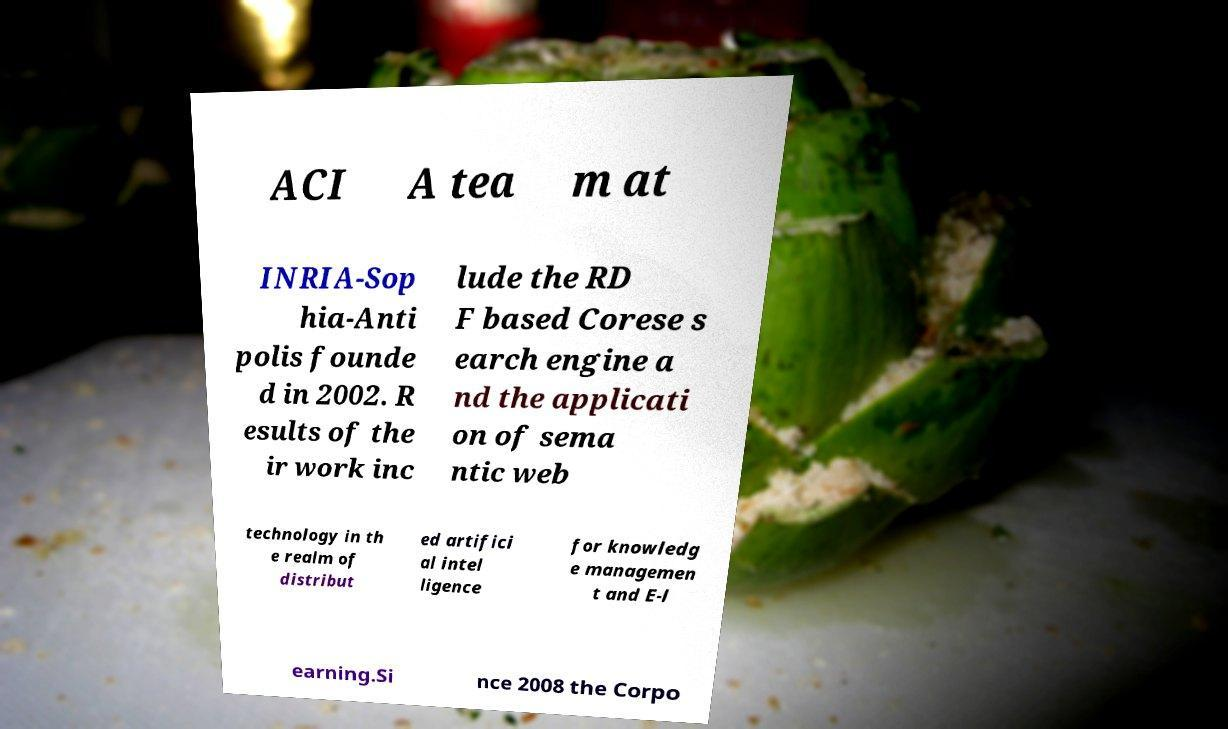Can you accurately transcribe the text from the provided image for me? ACI A tea m at INRIA-Sop hia-Anti polis founde d in 2002. R esults of the ir work inc lude the RD F based Corese s earch engine a nd the applicati on of sema ntic web technology in th e realm of distribut ed artifici al intel ligence for knowledg e managemen t and E-l earning.Si nce 2008 the Corpo 